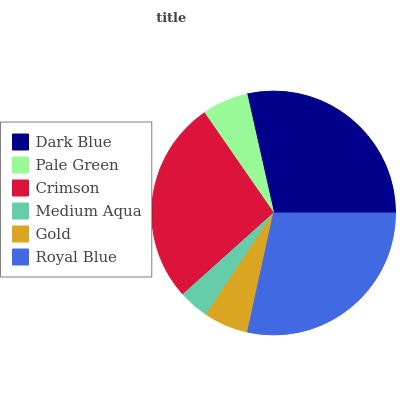Is Medium Aqua the minimum?
Answer yes or no. Yes. Is Dark Blue the maximum?
Answer yes or no. Yes. Is Pale Green the minimum?
Answer yes or no. No. Is Pale Green the maximum?
Answer yes or no. No. Is Dark Blue greater than Pale Green?
Answer yes or no. Yes. Is Pale Green less than Dark Blue?
Answer yes or no. Yes. Is Pale Green greater than Dark Blue?
Answer yes or no. No. Is Dark Blue less than Pale Green?
Answer yes or no. No. Is Crimson the high median?
Answer yes or no. Yes. Is Pale Green the low median?
Answer yes or no. Yes. Is Medium Aqua the high median?
Answer yes or no. No. Is Crimson the low median?
Answer yes or no. No. 